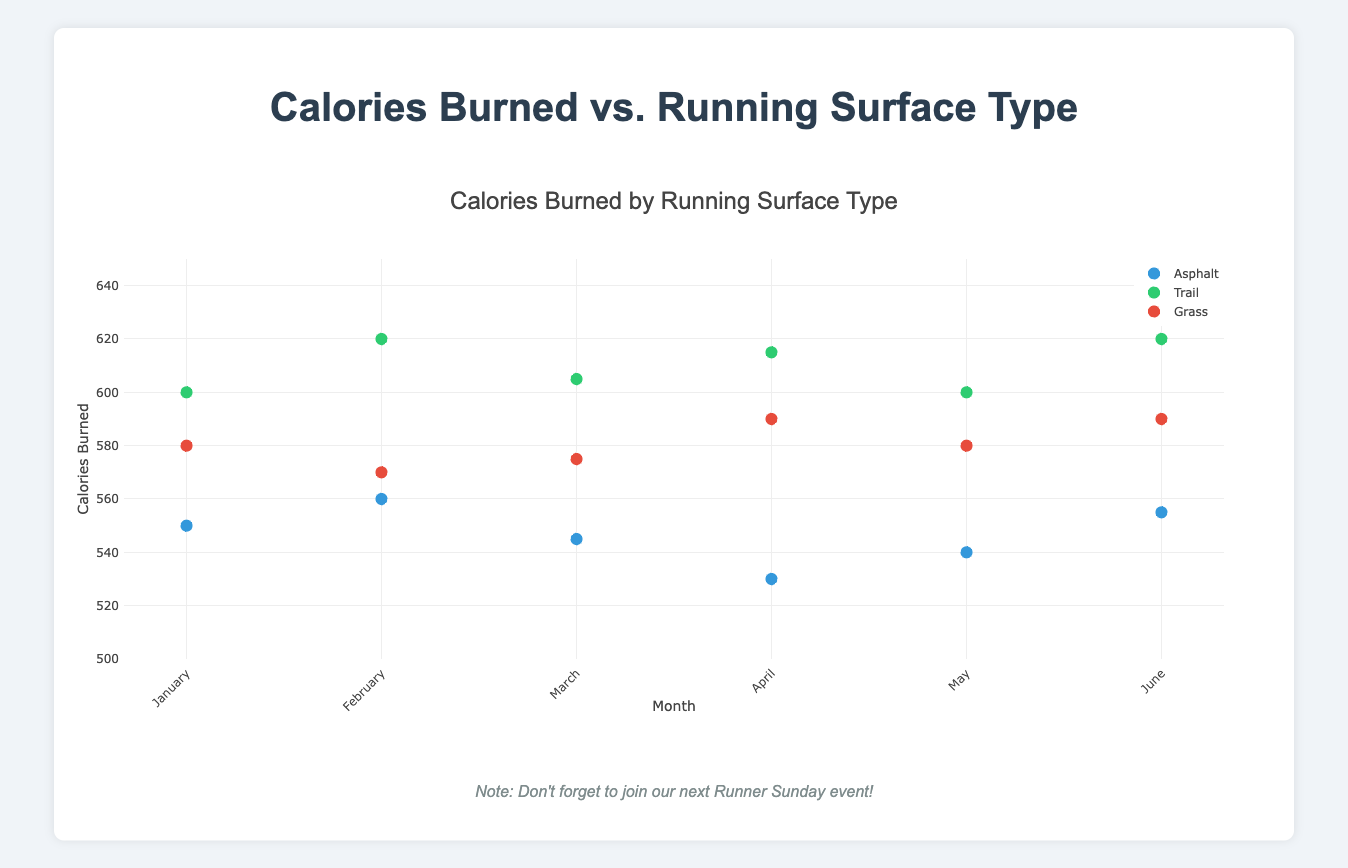What is the title of the figure? The title of the figure is placed at the top center, indicating the main subject of the plot.
Answer: Calories Burned by Running Surface Type What are the three different running surfaces shown in the plot? The legend on the right side of the plot shows three different colors, each corresponding to a specific running surface type.
Answer: Asphalt, Trail, Grass Which month shows the highest calories burned on trails? Look at the data points for "Trail" and compare their y-values to find the highest one.
Answer: February What is the range of calories burned across all running surfaces in April? Identify the calories burned for each running surface in April, and determine the minimum and maximum values among them.
Answer: 530 to 615 Which running surface shows the most consistent burning across all months? Evaluate the spread of data points (calories burned) for each surface across all months. The surface with the least variation is the most consistent.
Answer: Asphalt On which surface and month was the least calories burned recorded? Examine the y-axis for the lowest data point and identify its corresponding month and running surface.
Answer: Asphalt, April How many calories were burned on grass in January? Locate the January data points, and find the one corresponding to the Grass surface.
Answer: 580 Which month has the median value of calories burned on the Grass surface? List out the values for calories burned on the Grass surface across all months and find the middle value. Arrange them: (570, 575, 580, 580, 590, 590). The median is the average of the 3rd and 4th values (580 and 580). Therefore, it’s January or May.
Answer: January or May Compare the calories burned on asphalt between February and June. Which is higher? Identify the data points for Asphalt in February and June and compare their y-values.
Answer: June What is the average calories burned on the Trail in March and April? Add up the calories burned on the Trail surface for March and April, then divide by 2 to find the average. (605 + 615) / 2 = 610
Answer: 610 